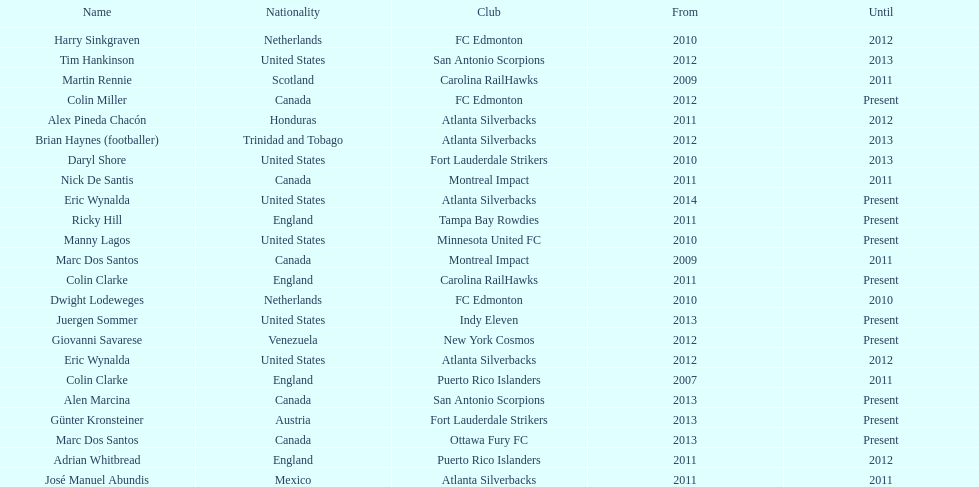Who is the last to coach the san antonio scorpions? Alen Marcina. 